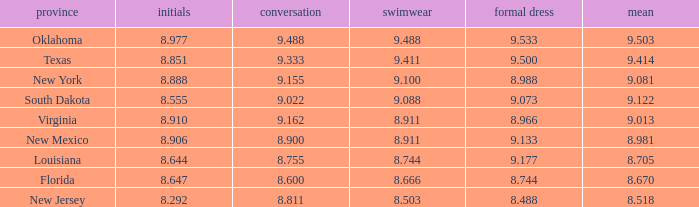 what's the evening gown where state is south dakota 9.073. 